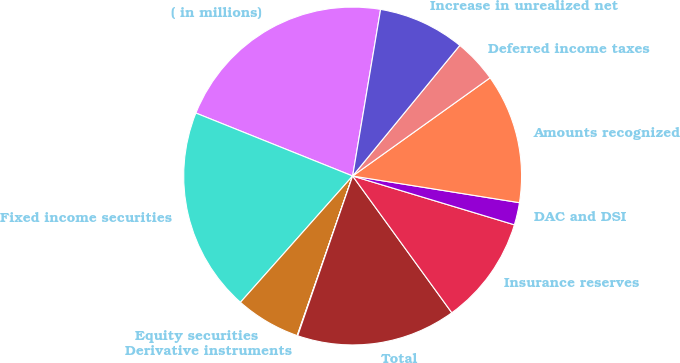Convert chart. <chart><loc_0><loc_0><loc_500><loc_500><pie_chart><fcel>( in millions)<fcel>Fixed income securities<fcel>Equity securities<fcel>Derivative instruments<fcel>Total<fcel>Insurance reserves<fcel>DAC and DSI<fcel>Amounts recognized<fcel>Deferred income taxes<fcel>Increase in unrealized net<nl><fcel>21.57%<fcel>19.52%<fcel>6.24%<fcel>0.05%<fcel>15.26%<fcel>10.35%<fcel>2.14%<fcel>12.4%<fcel>4.19%<fcel>8.29%<nl></chart> 